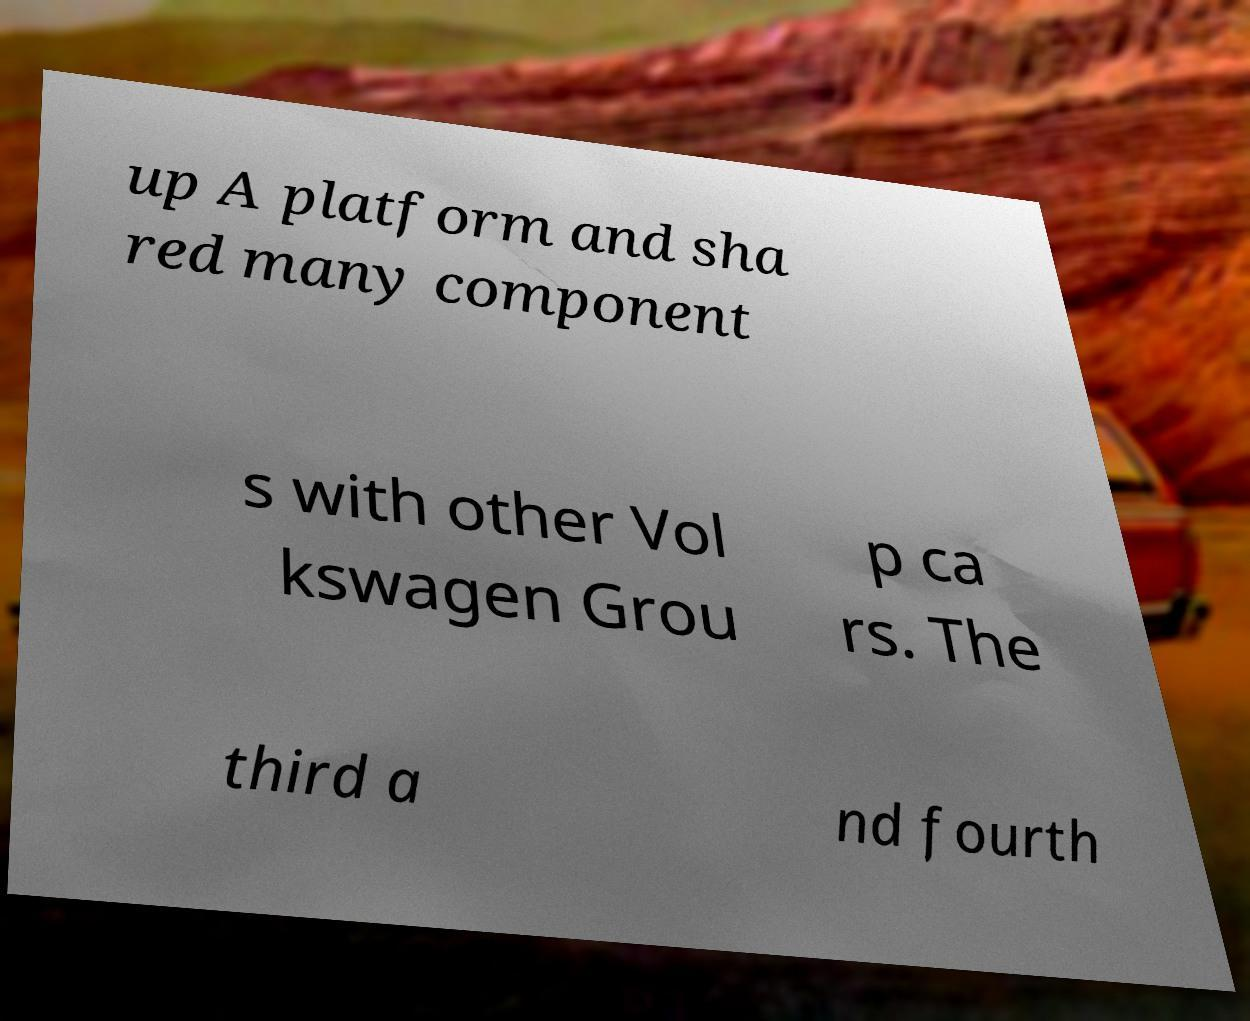There's text embedded in this image that I need extracted. Can you transcribe it verbatim? up A platform and sha red many component s with other Vol kswagen Grou p ca rs. The third a nd fourth 